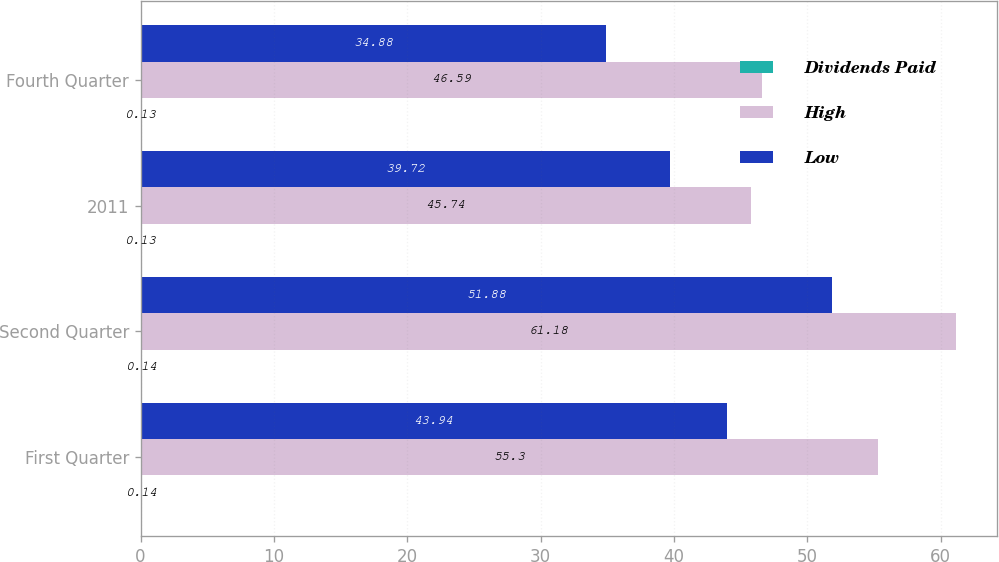Convert chart to OTSL. <chart><loc_0><loc_0><loc_500><loc_500><stacked_bar_chart><ecel><fcel>First Quarter<fcel>Second Quarter<fcel>2011<fcel>Fourth Quarter<nl><fcel>Dividends Paid<fcel>0.14<fcel>0.14<fcel>0.13<fcel>0.13<nl><fcel>High<fcel>55.3<fcel>61.18<fcel>45.74<fcel>46.59<nl><fcel>Low<fcel>43.94<fcel>51.88<fcel>39.72<fcel>34.88<nl></chart> 